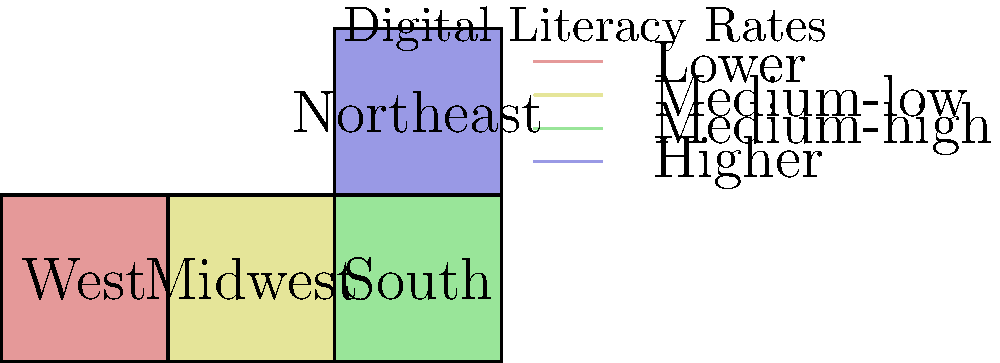Based on the color-coded map showing the geographic distribution of digital literacy rates across the country, which region appears to have the highest digital literacy rates, and how might this information inform policy decisions for digital transformation of government processes? To answer this question, let's analyze the map step-by-step:

1. The map divides the country into four regions: West, Midwest, South, and Northeast.

2. Each region is color-coded to represent different levels of digital literacy rates:
   - Light red (West): Lower
   - Light yellow (Midwest): Medium-low
   - Light green (South): Medium-high
   - Light blue (Northeast): Higher

3. Based on the color coding, the Northeast region (light blue) appears to have the highest digital literacy rates.

4. This information can inform policy decisions for digital transformation of government processes in several ways:

   a. Prioritization: The Northeast might be a good region to pilot new digital government services due to higher digital literacy rates, potentially leading to higher adoption rates.

   b. Resource allocation: Regions with lower digital literacy rates (e.g., the West) may require more resources for digital education and infrastructure development.

   c. Tailored approaches: Different strategies may be needed for each region. For example:
      - Northeast: Focus on advanced digital services
      - South: Build on existing digital literacy to expand services
      - Midwest and West: Emphasize basic digital skills training alongside new digital government initiatives

   d. Collaboration opportunities: The Northeast could potentially serve as a model or partner for other regions in implementing digital government processes.

   e. Digital divide considerations: Policy makers should address the apparent digital divide between regions to ensure equitable access to digital government services nationwide.

   f. Long-term planning: The map can guide the development of a phased approach to digital transformation, starting with regions of higher literacy and gradually expanding to others.
Answer: Northeast; informs prioritization, resource allocation, and tailored regional strategies for digital transformation. 